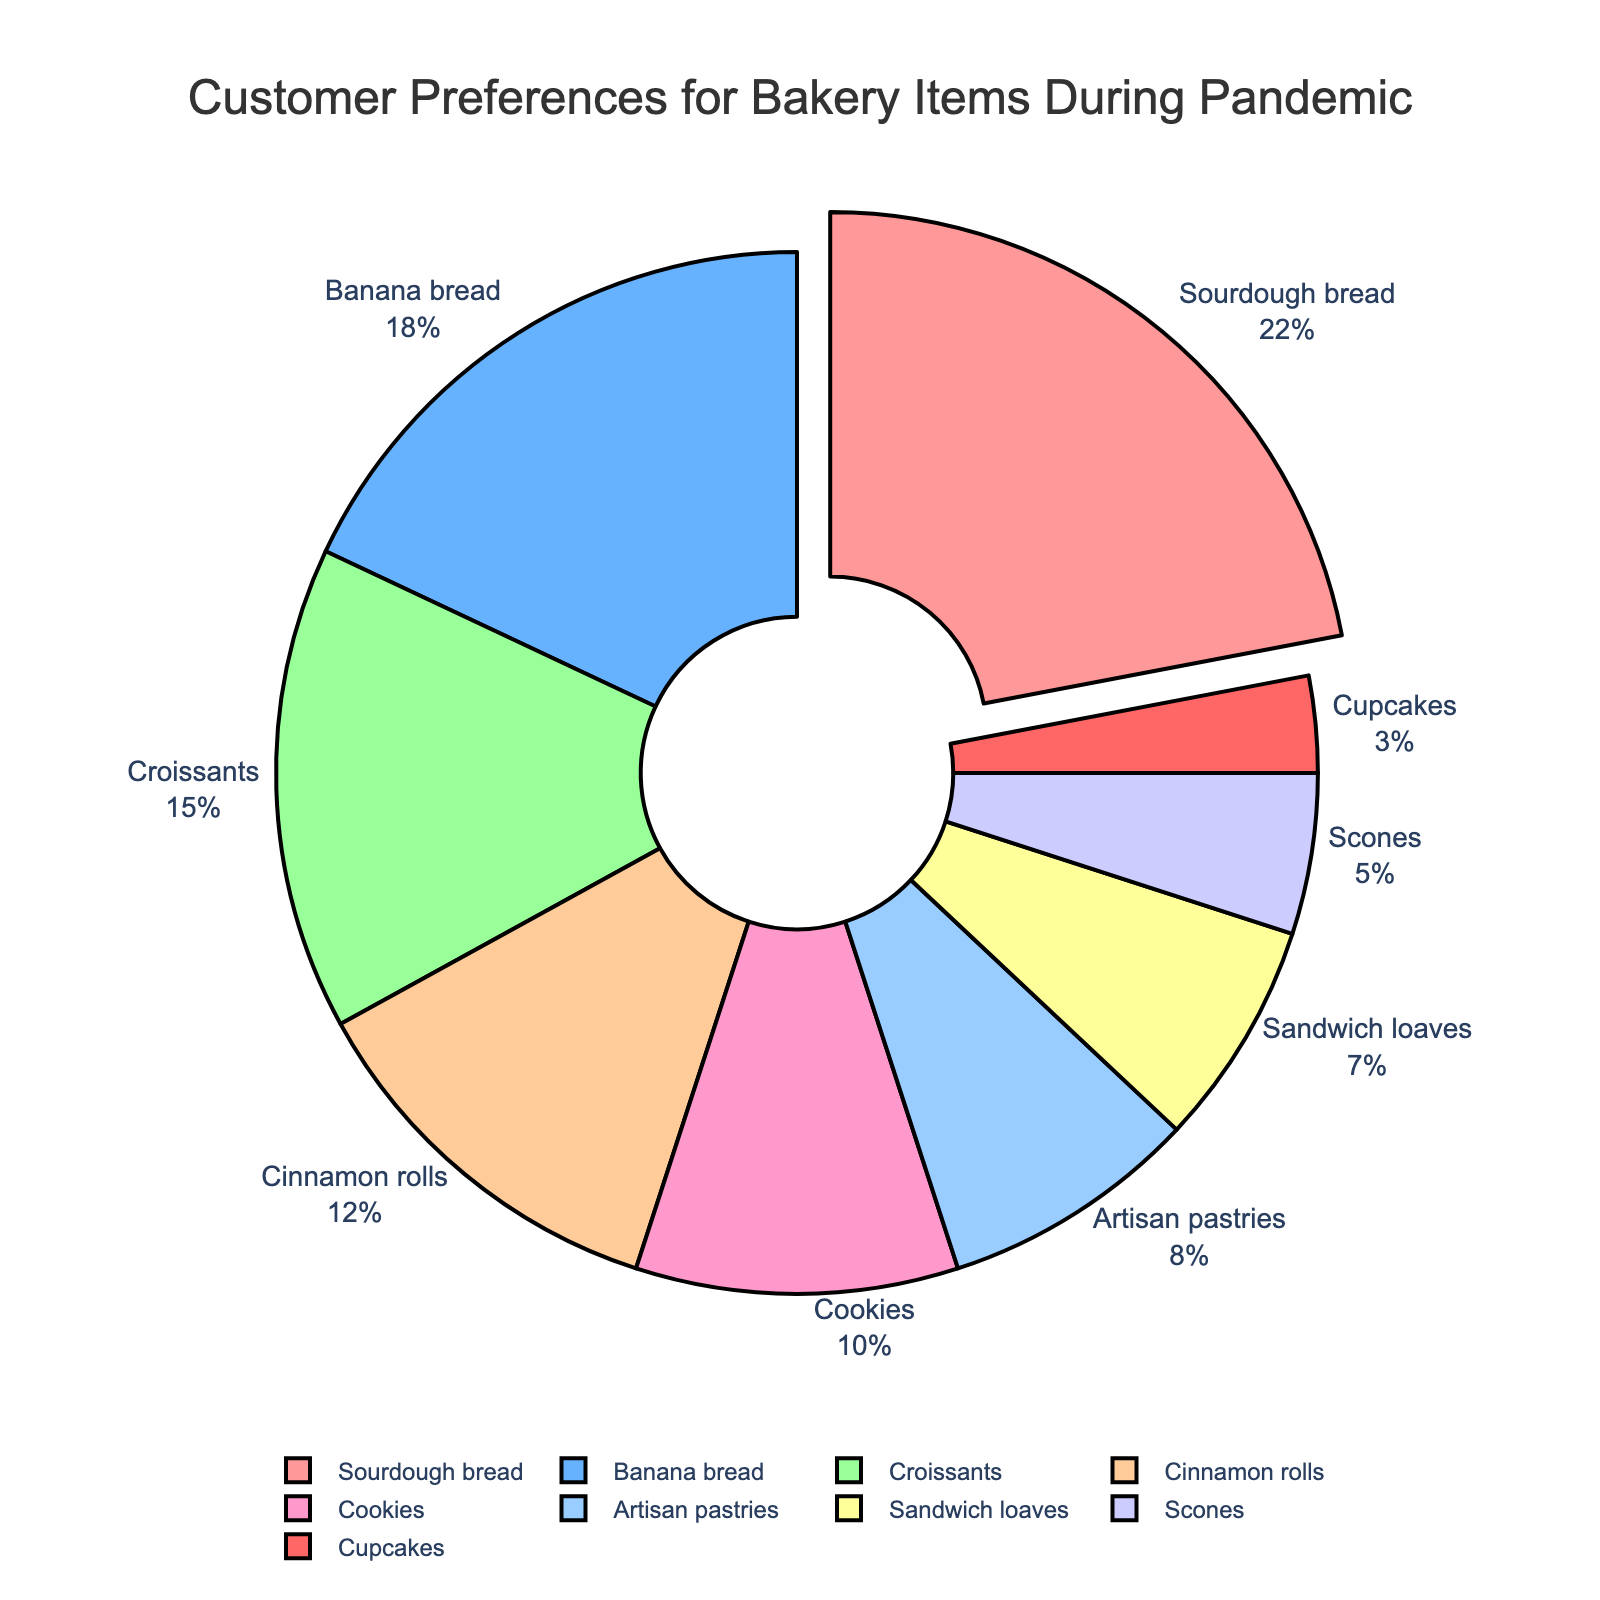What is the most preferred bakery item during the pandemic? The pie chart shows that Sourdough bread has the largest percentage and is visually pulled out from the rest of the items, indicating it is the most preferred.
Answer: Sourdough bread Which bakery item is least preferred by customers during the pandemic? The smallest segment in the pie chart represents Cupcakes at 3%.
Answer: Cupcakes How do the preferences for Croissants and Cinnamon rolls compare? Croissants have a larger segment in the pie chart with 15%, whereas Cinnamon rolls have 12%.
Answer: Croissants What percentage of customers prefer either Sourdough bread or Banana bread? Add the percentages of Sourdough bread (22%) and Banana bread (18%), which equals 40%.
Answer: 40% Which two items together have a higher preference than Sourdough bread alone? Combining Banana bread (18%) and Croissants (15%) gives 33%, which is higher than Sourdough bread’s 22%.
Answer: Banana bread and Croissants What is the difference in preference between Croissants and Scones? Subtract the percentage of Scones (5%) from the percentage of Croissants (15%), resulting in a difference of 10%.
Answer: 10% If Artisan pastries and Sandwich loaves are combined, what is their total percentage of preference? Add the percentages of Artisan pastries (8%) and Sandwich loaves (7%) to get 15%.
Answer: 15% Which bakery items fall within the middle 50% range of preferences? The middle 50% would include items adding up to percentages from 25% to 75%. Starting after Sourdough (22%), Banana bread (18%) and Croissants (15%) make up the next 33%, covering them within the middle range.
Answer: Banana bread and Croissants Is there a more popular choice than Cookies but less popular than Sourdough bread? Compare each item, and it shows that Banana bread (18%) and Croissants (15%) are both more popular than Cookies (10%) but less than Sourdough bread (22%).
Answer: Banana bread and Croissants Which items together constitute less than 20%? Combining the smallest segments: Cupcakes (3%) and Scones (5%) = 8%; adding Sandwich loaves (7%) = 15%; including Artisan pastries (8%) makes it 23%, which is too high. Therefore, only Cupcakes, Scones, and Sandwich loaves (collectively 15%) fit.
Answer: Cupcakes, Scones, and Sandwich loaves 